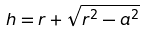Convert formula to latex. <formula><loc_0><loc_0><loc_500><loc_500>h = r + \sqrt { r ^ { 2 } - a ^ { 2 } }</formula> 